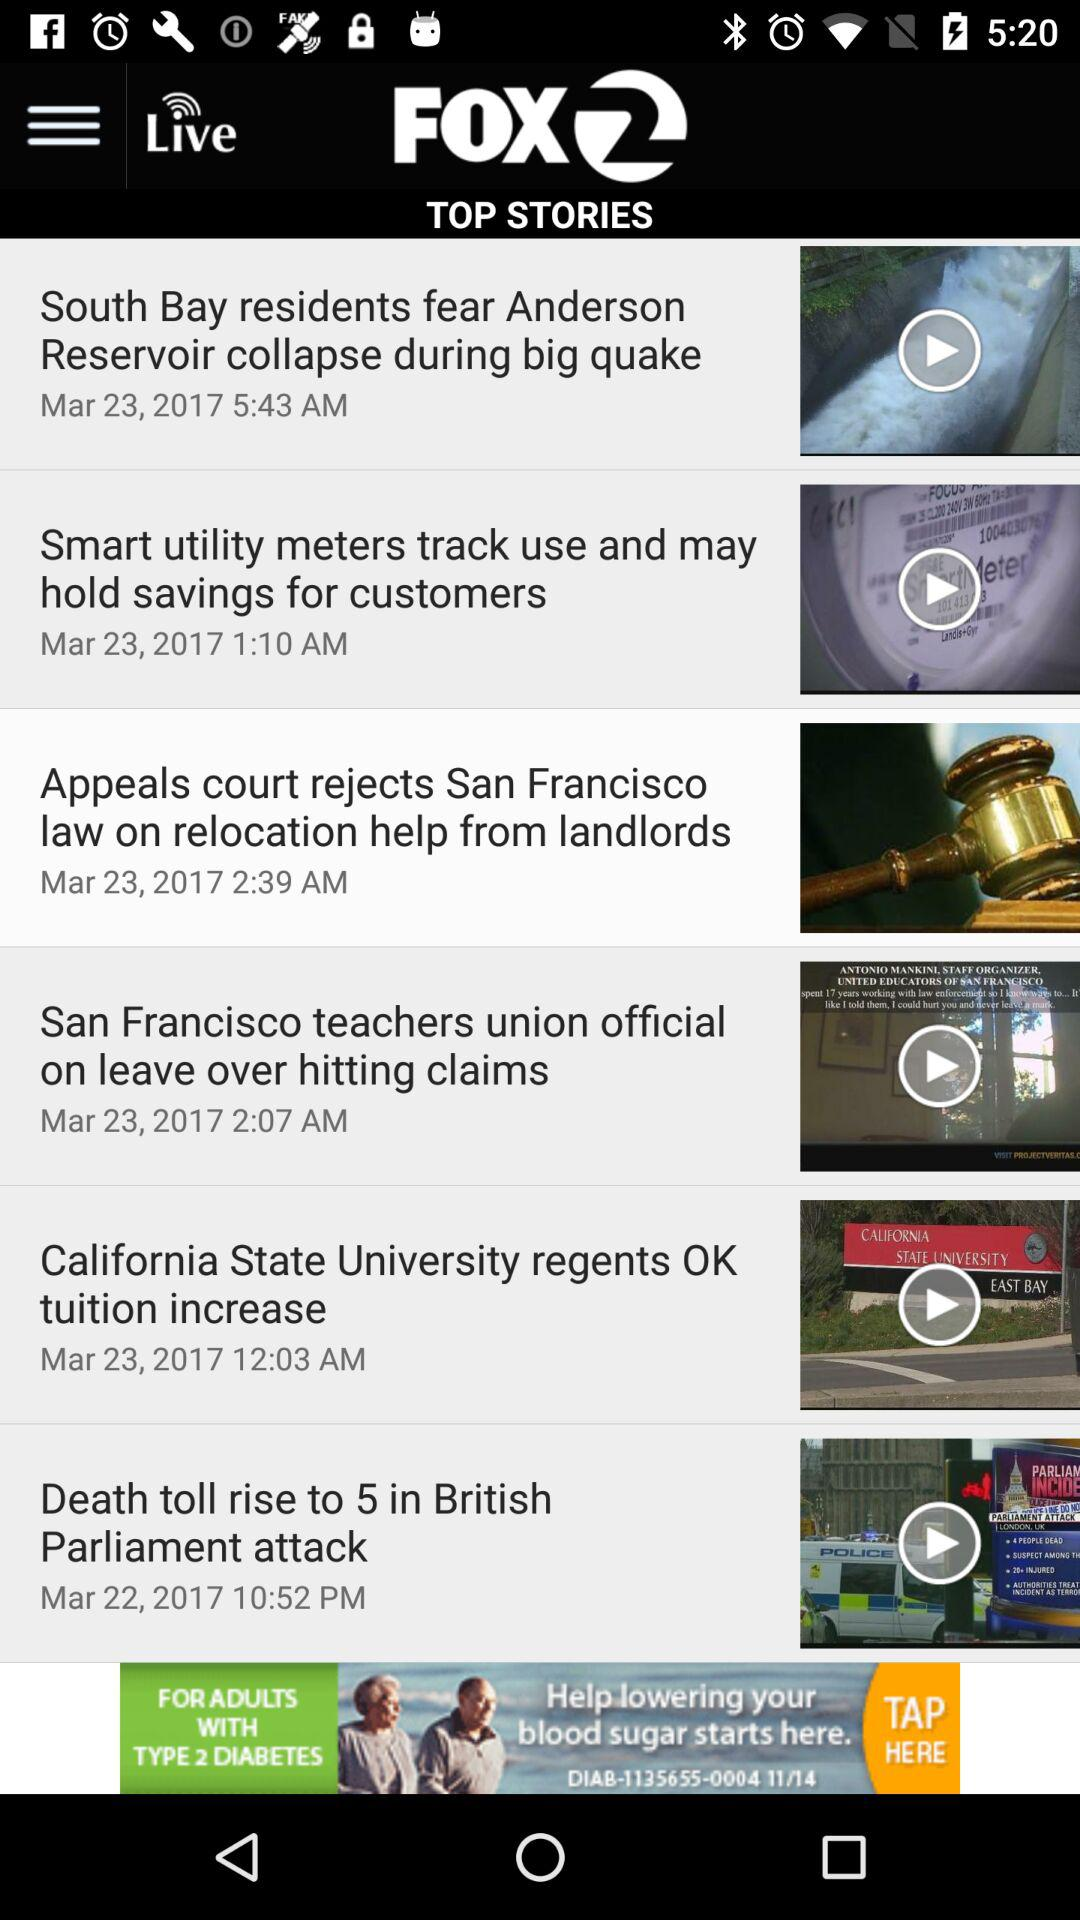What is the name of the application? The name of the application is "KTVU FOX 2". 